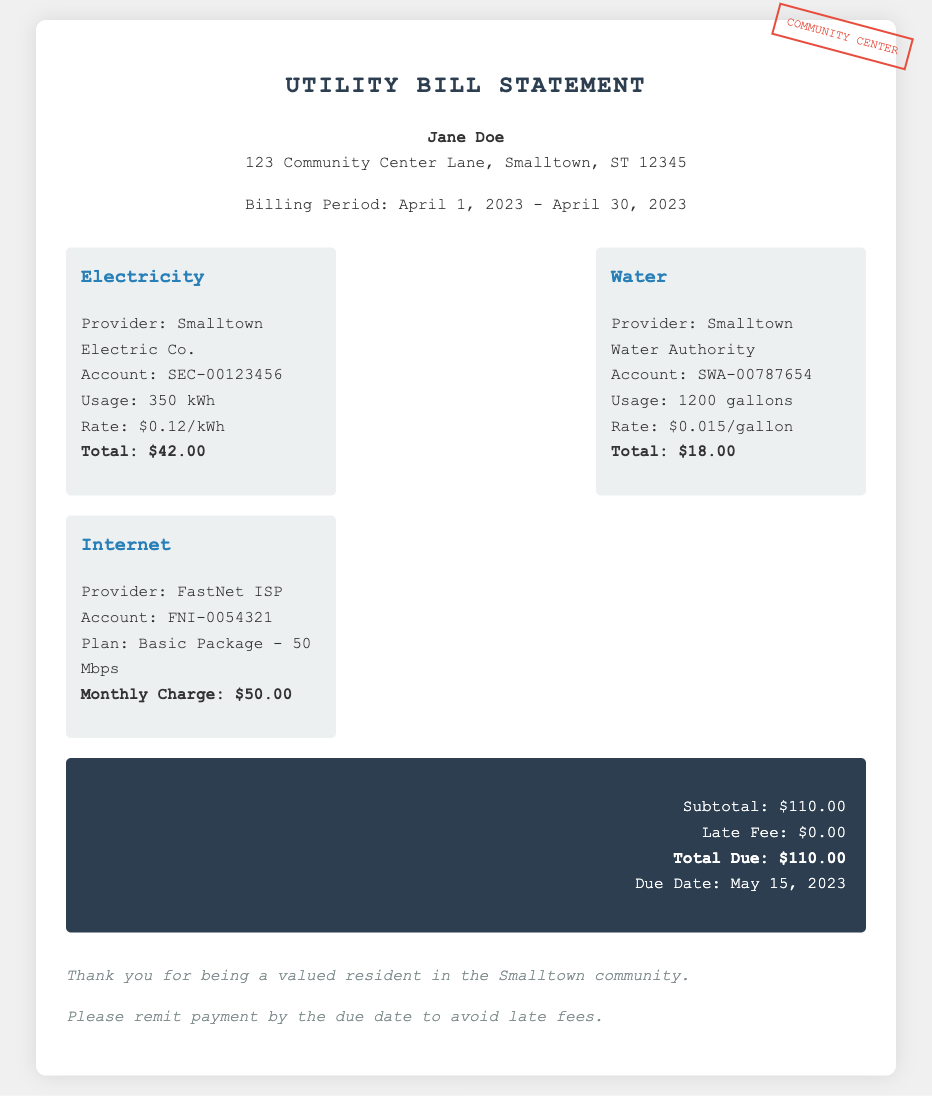What is the billing period? The billing period is specified as the time frame for which the utilities are being billed, which is April 1, 2023 - April 30, 2023.
Answer: April 1, 2023 - April 30, 2023 What is the total due amount? The total due amount is presented in the total section of the bill, which is calculated from the subtotal and any fees applied.
Answer: $110.00 Who is the electricity provider? The electricity provider is listed with specific account information, which is part of the charges section of the bill.
Answer: Smalltown Electric Co What was the water usage in gallons? This information is part of the water charges and indicates how much was used during the billing period.
Answer: 1200 gallons What is the rate per kWh for electricity? The bill specifies the rate charged for electricity usage, which is needed to calculate the total electricity charge.
Answer: $0.12/kWh Calculate the total charges for electricity and water. The total charges are calculated by adding the electricity total ($42.00) and the water total ($18.00).
Answer: $60.00 Where should the payment be remitted to avoid late fees? The document notes the importance of remitting payment to maintain good standing, which corresponds to being a valued resident in the community.
Answer: Smalltown community What is the account number for internet service? The account number is specifically provided under the internet charge section of the document.
Answer: FNI-0054321 What is the due date for the payment? The due date is provided in the total section of the bill and indicates when the payment should be made to avoid penalties.
Answer: May 15, 2023 